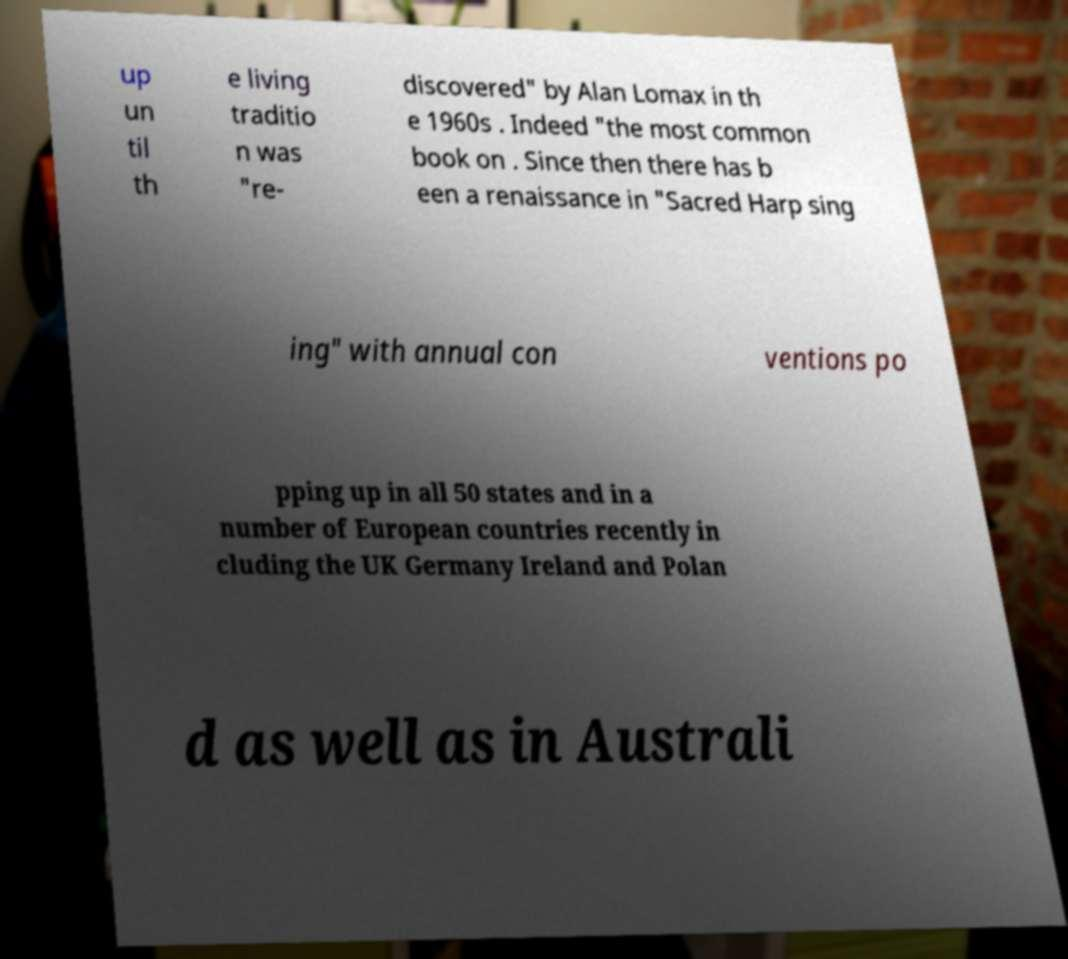Could you assist in decoding the text presented in this image and type it out clearly? up un til th e living traditio n was "re- discovered" by Alan Lomax in th e 1960s . Indeed "the most common book on . Since then there has b een a renaissance in "Sacred Harp sing ing" with annual con ventions po pping up in all 50 states and in a number of European countries recently in cluding the UK Germany Ireland and Polan d as well as in Australi 